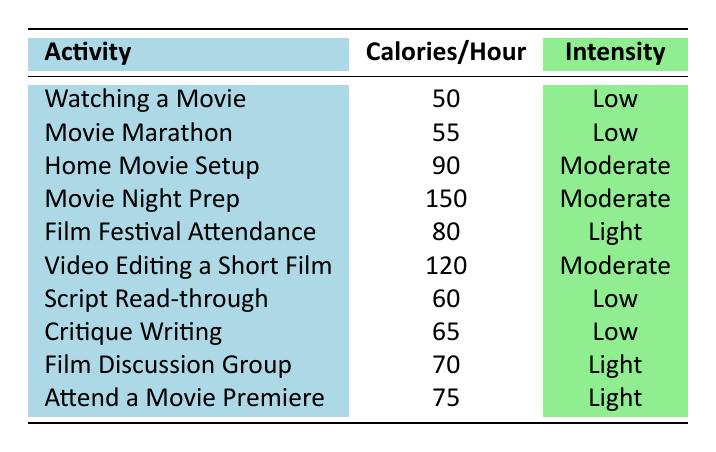What is the activity that burns the most calories per hour? The activity "Movie Night Prep" burns the most calories at 150 per hour, as shown in the "Calories/Hour" column.
Answer: Movie Night Prep How many calories are burned during a video editing session for one hour? The table indicates that "Video Editing a Short Film" results in burning 120 calories in one hour.
Answer: 120 Which activities have a low intensity level? The activities with low intensity are "Watching a Movie," "Movie Marathon," "Script Read-through," and "Critique Writing."
Answer: Watching a Movie, Movie Marathon, Script Read-through, Critique Writing What is the average number of calories burned for all listed activities? The total calories burned for all activities is (50 + 55 + 90 + 150 + 80 + 120 + 60 + 65 + 70 + 75) =  740 calories. There are 10 activities, so the average is 740/10 = 74 calories per hour.
Answer: 74 Is it true that attending a film festival burns more calories than watching a movie? Yes, the table shows that "Film Festival Attendance" burns 80 calories, which is more than 50 calories burned while "Watching a Movie."
Answer: Yes Which activity has a higher calorie burn, "Home Movie Setup" or "Attend a Movie Premiere"? "Home Movie Setup" burns 90 calories per hour while "Attend a Movie Premiere" burns 75 calories per hour. Since 90 is greater than 75, "Home Movie Setup" has a higher calorie burn.
Answer: Home Movie Setup What is the total calories burned if one does a movie marathon followed by a script read-through in one hour each? For a movie marathon, 55 calories are burned, and for a script read-through, 60 calories are burned. The total is 55 + 60 = 115 calories.
Answer: 115 How does the calorie burn of a "Film Discussion Group" compare to that of "Critique Writing"? The "Film Discussion Group" burns 70 calories while "Critique Writing" burns 65 calories. Therefore, the discussion group burns 5 more calories.
Answer: 5 more calories What is the intensity level associated with "Movie Night Prep"? The "Movie Night Prep" is classified under the intensity level "Moderate," as mentioned in the table.
Answer: Moderate If someone spends an entire hour doing "Video Editing" then "Attend a Movie Premiere", what is the total calorie burn for both activities? "Video Editing a Short Film" burns 120 calories, and "Attend a Movie Premiere" burns 75 calories. Adding both gives 120 + 75 = 195 calories total.
Answer: 195 